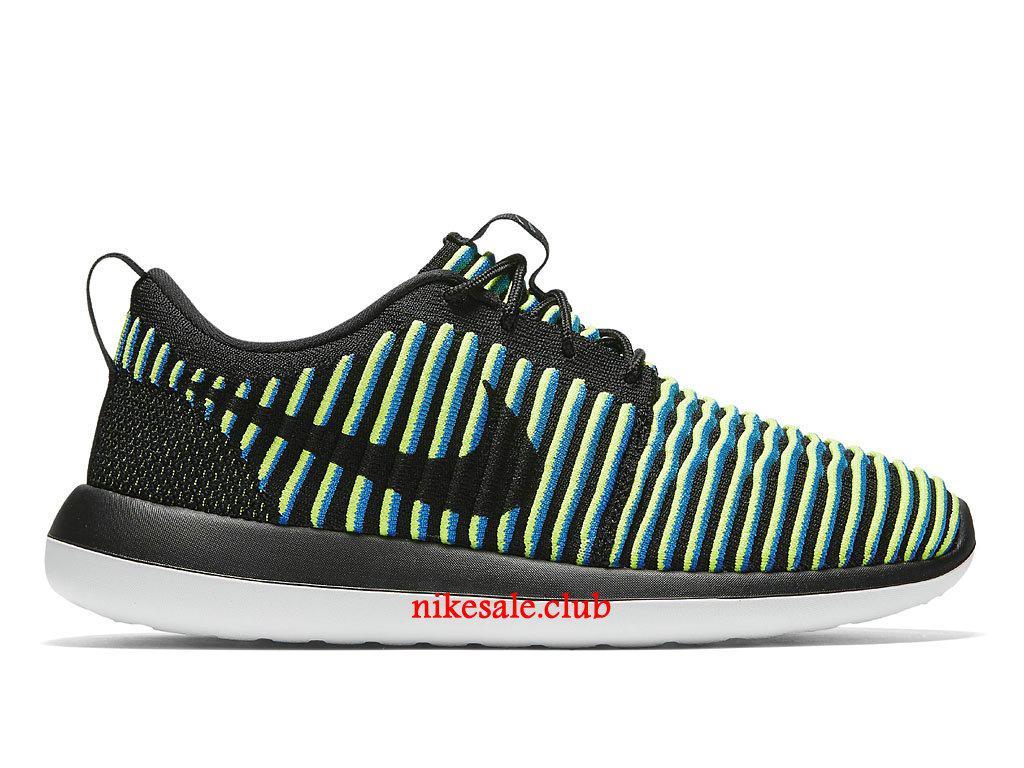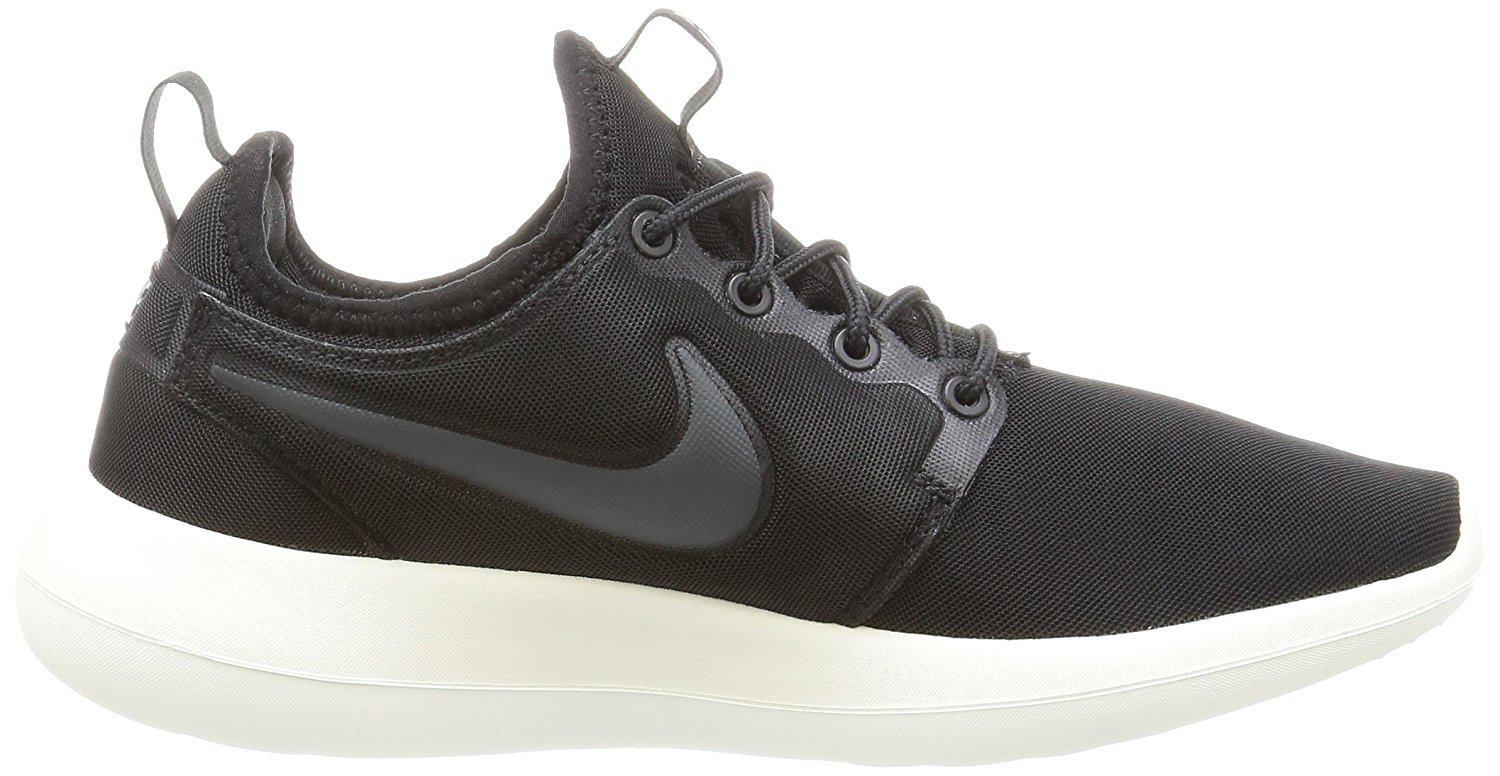The first image is the image on the left, the second image is the image on the right. Considering the images on both sides, is "The combined images show exactly two left-facing sneakers." valid? Answer yes or no. No. The first image is the image on the left, the second image is the image on the right. For the images displayed, is the sentence "There are two shoes, and one of them is striped, while the other is a plain color." factually correct? Answer yes or no. Yes. 